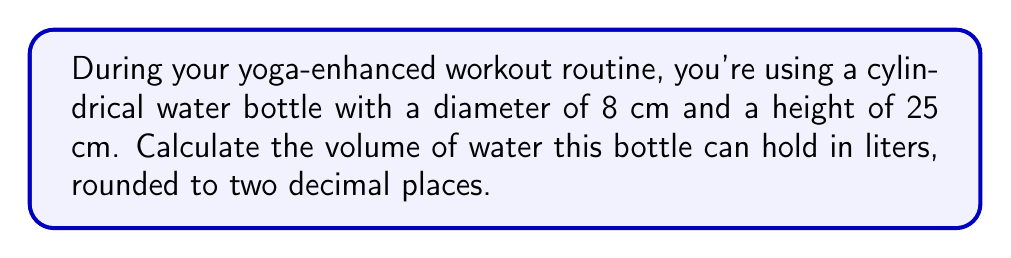Solve this math problem. To solve this problem, let's follow these steps:

1) The formula for the volume of a cylinder is:
   $$V = \pi r^2 h$$
   where $r$ is the radius of the base and $h$ is the height.

2) We're given the diameter, so we need to find the radius:
   $$r = \frac{diameter}{2} = \frac{8 \text{ cm}}{2} = 4 \text{ cm}$$

3) Now we can substitute the values into our formula:
   $$V = \pi (4 \text{ cm})^2 (25 \text{ cm})$$

4) Simplify:
   $$V = \pi (16 \text{ cm}^2) (25 \text{ cm}) = 400\pi \text{ cm}^3$$

5) Calculate:
   $$V \approx 1256.64 \text{ cm}^3$$

6) Convert cubic centimeters to liters:
   $$1256.64 \text{ cm}^3 \times \frac{1 \text{ L}}{1000 \text{ cm}^3} \approx 1.26 \text{ L}$$

Therefore, the water bottle can hold approximately 1.26 liters.
Answer: 1.26 L 